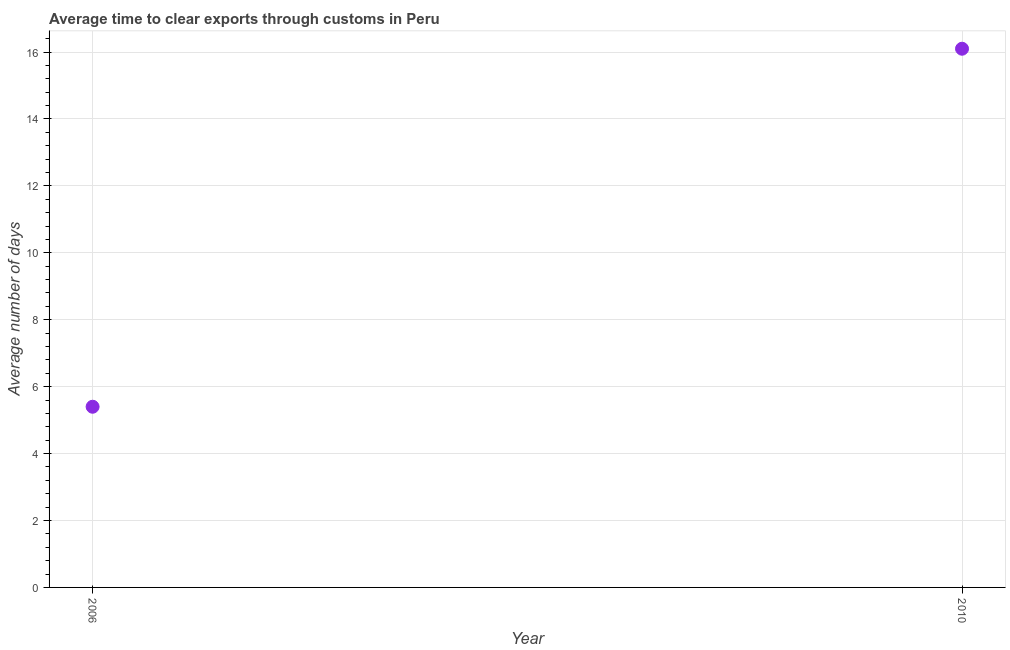Across all years, what is the minimum time to clear exports through customs?
Ensure brevity in your answer.  5.4. In which year was the time to clear exports through customs maximum?
Offer a terse response. 2010. In which year was the time to clear exports through customs minimum?
Your answer should be very brief. 2006. What is the sum of the time to clear exports through customs?
Your answer should be very brief. 21.5. What is the difference between the time to clear exports through customs in 2006 and 2010?
Offer a very short reply. -10.7. What is the average time to clear exports through customs per year?
Provide a short and direct response. 10.75. What is the median time to clear exports through customs?
Give a very brief answer. 10.75. In how many years, is the time to clear exports through customs greater than 2.4 days?
Your response must be concise. 2. Do a majority of the years between 2006 and 2010 (inclusive) have time to clear exports through customs greater than 1.2000000000000002 days?
Provide a succinct answer. Yes. What is the ratio of the time to clear exports through customs in 2006 to that in 2010?
Your response must be concise. 0.34. Is the time to clear exports through customs in 2006 less than that in 2010?
Make the answer very short. Yes. In how many years, is the time to clear exports through customs greater than the average time to clear exports through customs taken over all years?
Ensure brevity in your answer.  1. Does the time to clear exports through customs monotonically increase over the years?
Make the answer very short. Yes. How many dotlines are there?
Provide a short and direct response. 1. How many years are there in the graph?
Your answer should be compact. 2. What is the difference between two consecutive major ticks on the Y-axis?
Offer a very short reply. 2. What is the title of the graph?
Keep it short and to the point. Average time to clear exports through customs in Peru. What is the label or title of the X-axis?
Make the answer very short. Year. What is the label or title of the Y-axis?
Ensure brevity in your answer.  Average number of days. What is the difference between the Average number of days in 2006 and 2010?
Provide a short and direct response. -10.7. What is the ratio of the Average number of days in 2006 to that in 2010?
Provide a succinct answer. 0.34. 